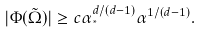Convert formula to latex. <formula><loc_0><loc_0><loc_500><loc_500>| \Phi ( \tilde { \Omega } ) | \geq c \alpha _ { ^ { * } } ^ { d / ( d - 1 ) } \alpha ^ { 1 / ( d - 1 ) } .</formula> 